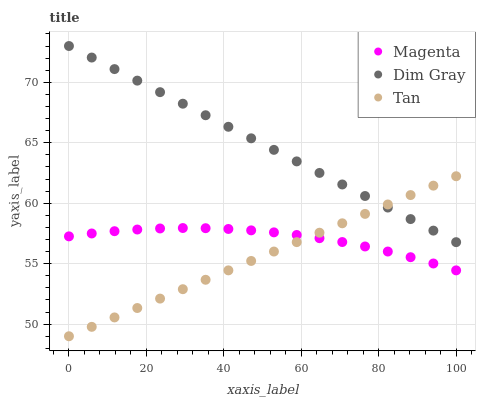Does Tan have the minimum area under the curve?
Answer yes or no. Yes. Does Dim Gray have the maximum area under the curve?
Answer yes or no. Yes. Does Dim Gray have the minimum area under the curve?
Answer yes or no. No. Does Tan have the maximum area under the curve?
Answer yes or no. No. Is Tan the smoothest?
Answer yes or no. Yes. Is Magenta the roughest?
Answer yes or no. Yes. Is Dim Gray the smoothest?
Answer yes or no. No. Is Dim Gray the roughest?
Answer yes or no. No. Does Tan have the lowest value?
Answer yes or no. Yes. Does Dim Gray have the lowest value?
Answer yes or no. No. Does Dim Gray have the highest value?
Answer yes or no. Yes. Does Tan have the highest value?
Answer yes or no. No. Is Magenta less than Dim Gray?
Answer yes or no. Yes. Is Dim Gray greater than Magenta?
Answer yes or no. Yes. Does Tan intersect Dim Gray?
Answer yes or no. Yes. Is Tan less than Dim Gray?
Answer yes or no. No. Is Tan greater than Dim Gray?
Answer yes or no. No. Does Magenta intersect Dim Gray?
Answer yes or no. No. 